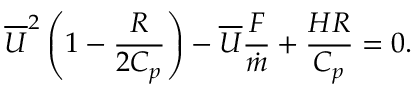<formula> <loc_0><loc_0><loc_500><loc_500>{ \overline { U } } ^ { 2 } \left ( { 1 - { \frac { R } { 2 C _ { p } } } } \right ) - { \overline { U } } { \frac { F } { \dot { m } } } + { \frac { H R } { C _ { p } } } = 0 .</formula> 